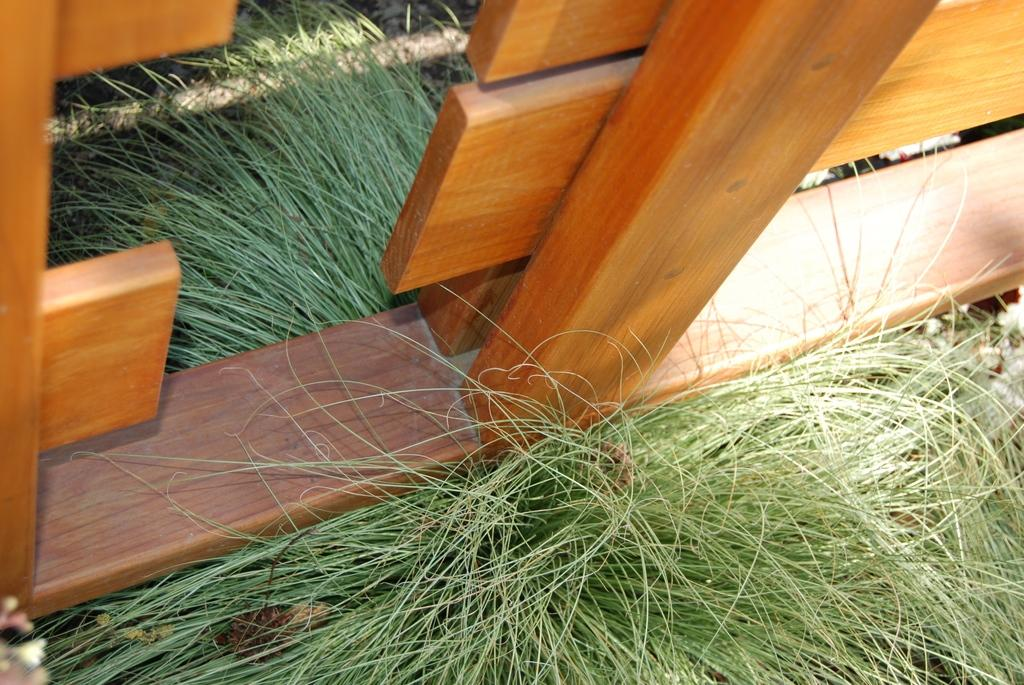What type of fence is visible in the image? There is a wooden fence in the image. What color is the grass in the image? The grass in the image is green. Where is the nearest hospital to the location depicted in the image? The provided facts do not mention a hospital or its location, so it cannot be determined from the image. Can you see a wren perched on the wooden fence in the image? There is no mention of a wren or any bird in the image, so it cannot be determined from the image. 